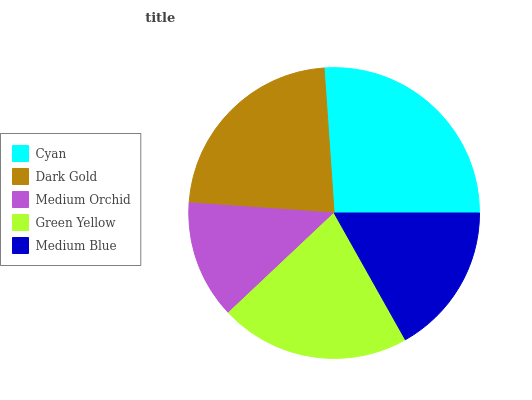Is Medium Orchid the minimum?
Answer yes or no. Yes. Is Cyan the maximum?
Answer yes or no. Yes. Is Dark Gold the minimum?
Answer yes or no. No. Is Dark Gold the maximum?
Answer yes or no. No. Is Cyan greater than Dark Gold?
Answer yes or no. Yes. Is Dark Gold less than Cyan?
Answer yes or no. Yes. Is Dark Gold greater than Cyan?
Answer yes or no. No. Is Cyan less than Dark Gold?
Answer yes or no. No. Is Green Yellow the high median?
Answer yes or no. Yes. Is Green Yellow the low median?
Answer yes or no. Yes. Is Medium Orchid the high median?
Answer yes or no. No. Is Cyan the low median?
Answer yes or no. No. 